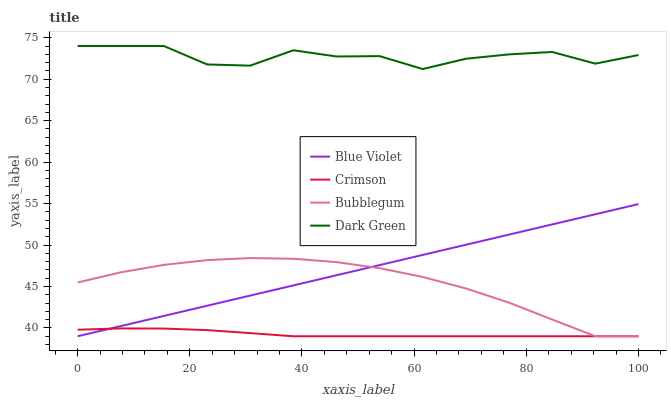Does Bubblegum have the minimum area under the curve?
Answer yes or no. No. Does Bubblegum have the maximum area under the curve?
Answer yes or no. No. Is Bubblegum the smoothest?
Answer yes or no. No. Is Bubblegum the roughest?
Answer yes or no. No. Does Dark Green have the lowest value?
Answer yes or no. No. Does Bubblegum have the highest value?
Answer yes or no. No. Is Blue Violet less than Dark Green?
Answer yes or no. Yes. Is Dark Green greater than Bubblegum?
Answer yes or no. Yes. Does Blue Violet intersect Dark Green?
Answer yes or no. No. 